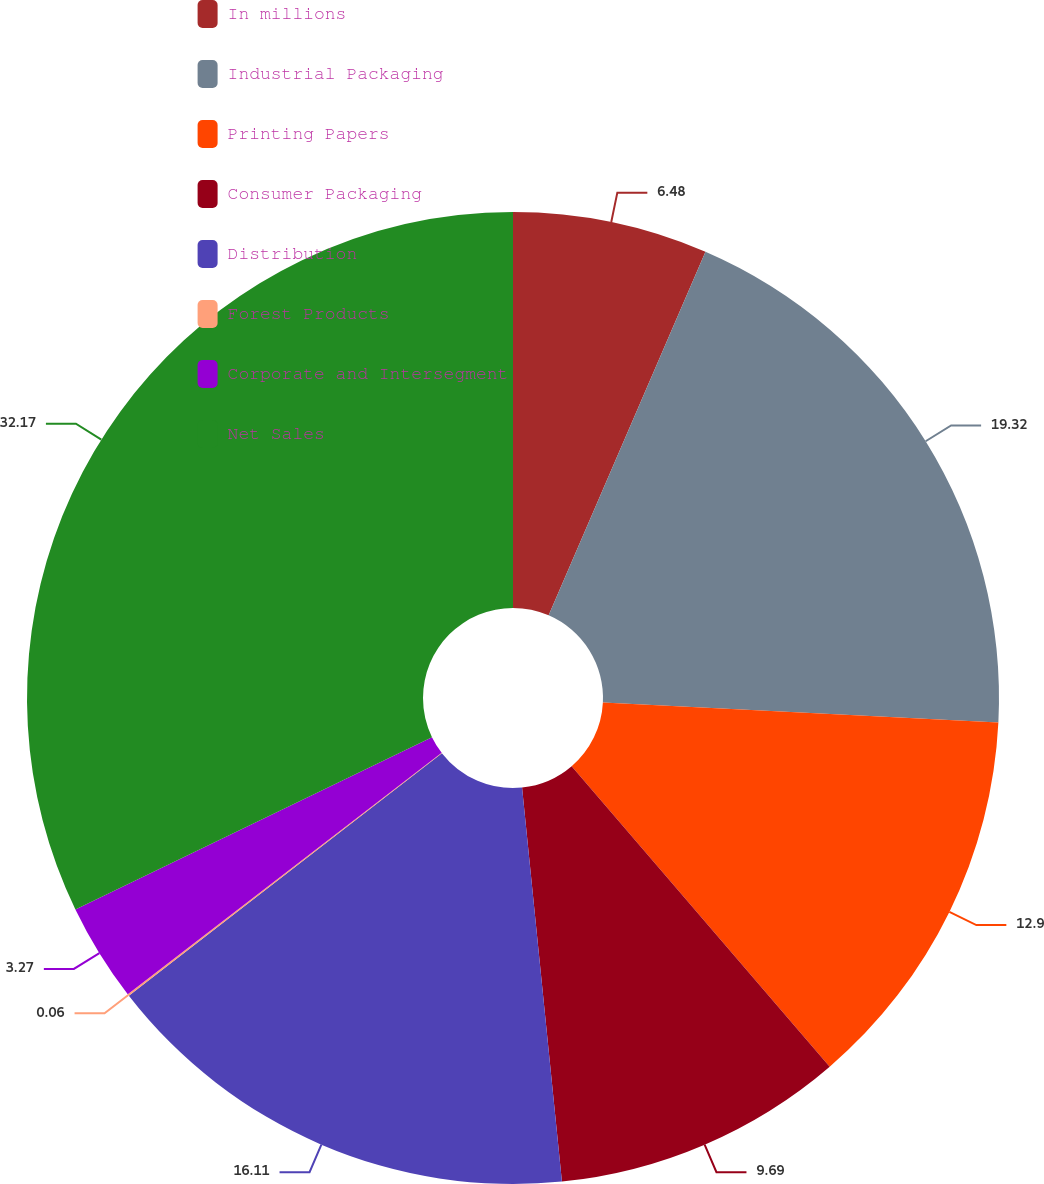Convert chart to OTSL. <chart><loc_0><loc_0><loc_500><loc_500><pie_chart><fcel>In millions<fcel>Industrial Packaging<fcel>Printing Papers<fcel>Consumer Packaging<fcel>Distribution<fcel>Forest Products<fcel>Corporate and Intersegment<fcel>Net Sales<nl><fcel>6.48%<fcel>19.32%<fcel>12.9%<fcel>9.69%<fcel>16.11%<fcel>0.06%<fcel>3.27%<fcel>32.16%<nl></chart> 